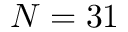<formula> <loc_0><loc_0><loc_500><loc_500>N = 3 1</formula> 